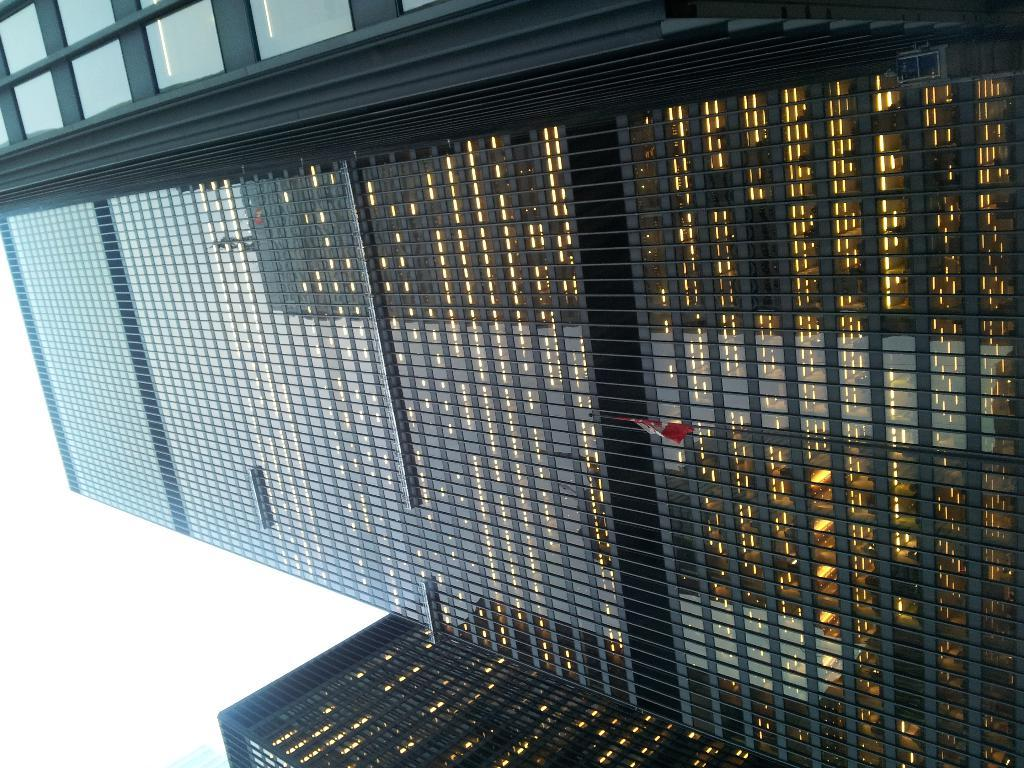What type of structures are present in the image? There are skyscrapers and buildings in the image. What feature do the buildings have in common? The buildings have glass windows. What is the condition of the sky in the image? The sky is cloudy in the image. What type of bait is being used to catch fish in the image? There is no indication of fishing or bait in the image; it features skyscrapers and buildings with glass windows and a cloudy sky. What is the profit margin for the buildings in the image? The image does not provide information about the profitability of the buildings; it only shows their appearance and the sky's condition. 